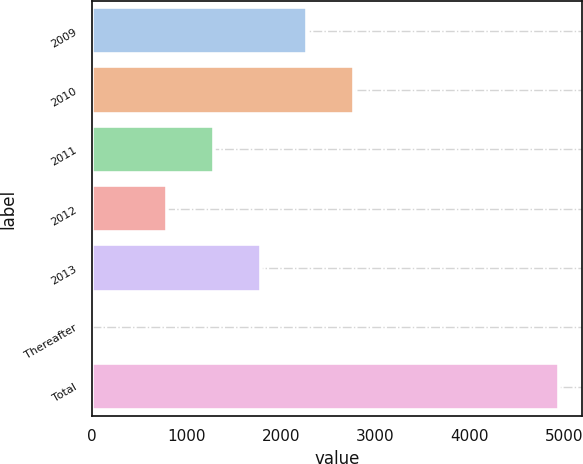Convert chart. <chart><loc_0><loc_0><loc_500><loc_500><bar_chart><fcel>2009<fcel>2010<fcel>2011<fcel>2012<fcel>2013<fcel>Thereafter<fcel>Total<nl><fcel>2280.3<fcel>2774.4<fcel>1292.1<fcel>798<fcel>1786.2<fcel>3<fcel>4944<nl></chart> 